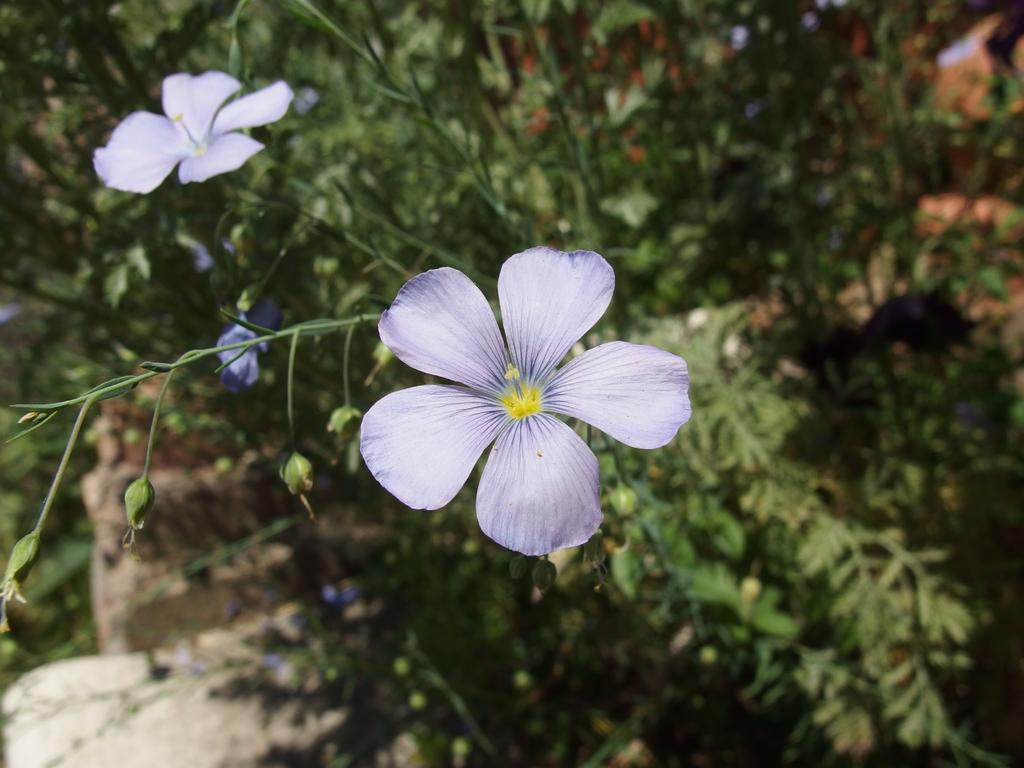What type of living organisms can be seen in the image? Plants and flowers are visible in the image. Are there any animals present in the image? Yes, there are birds in the image. Can you describe the plants in the image? The plants in the image have flowers. What type of dinosaurs can be seen in the image? There are no dinosaurs present in the image; it features plants, flowers, and birds. What color is the pail used by the birds in the image? There is no pail present in the image, so it cannot be determined what color it might be. 